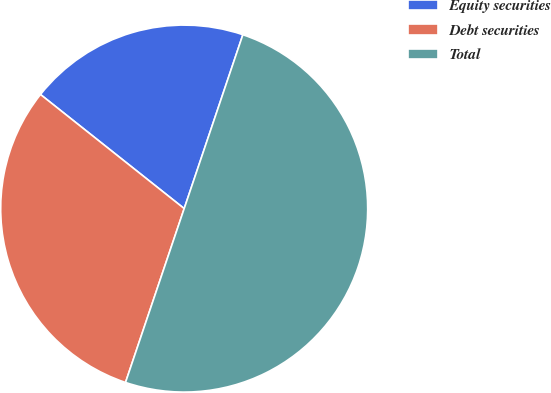<chart> <loc_0><loc_0><loc_500><loc_500><pie_chart><fcel>Equity securities<fcel>Debt securities<fcel>Total<nl><fcel>19.5%<fcel>30.5%<fcel>50.0%<nl></chart> 